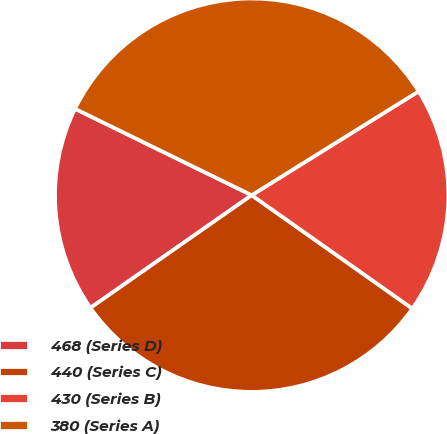<chart> <loc_0><loc_0><loc_500><loc_500><pie_chart><fcel>468 (Series D)<fcel>440 (Series C)<fcel>430 (Series B)<fcel>380 (Series A)<nl><fcel>16.95%<fcel>30.51%<fcel>18.64%<fcel>33.9%<nl></chart> 